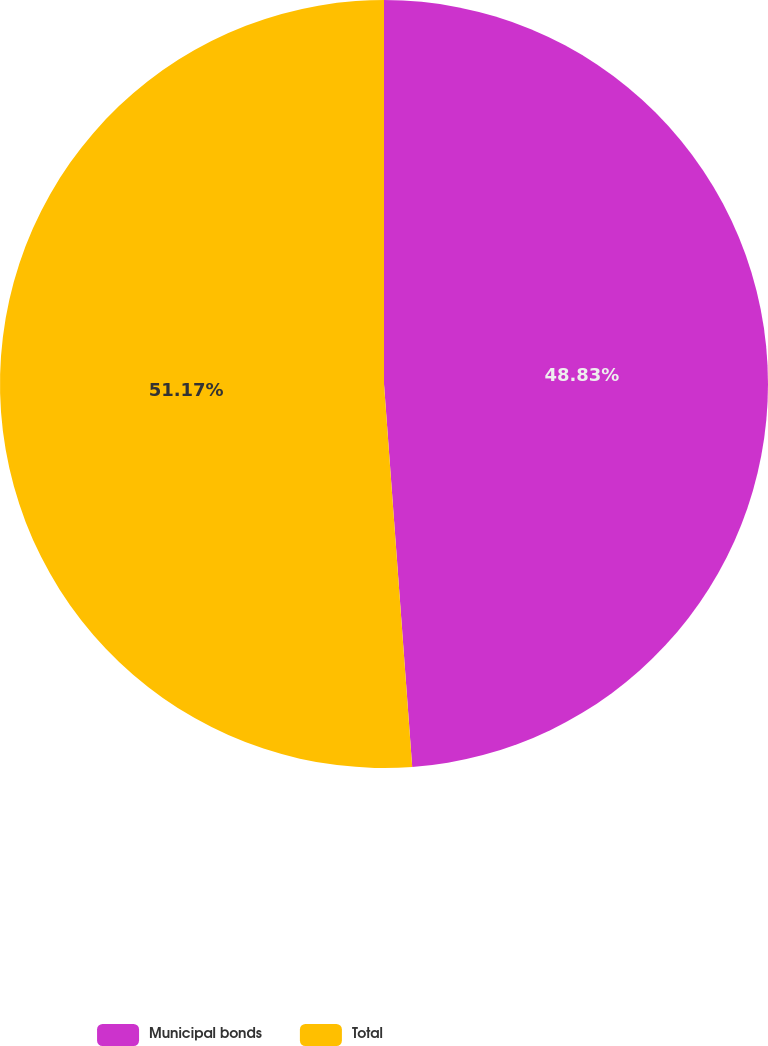Convert chart to OTSL. <chart><loc_0><loc_0><loc_500><loc_500><pie_chart><fcel>Municipal bonds<fcel>Total<nl><fcel>48.83%<fcel>51.17%<nl></chart> 